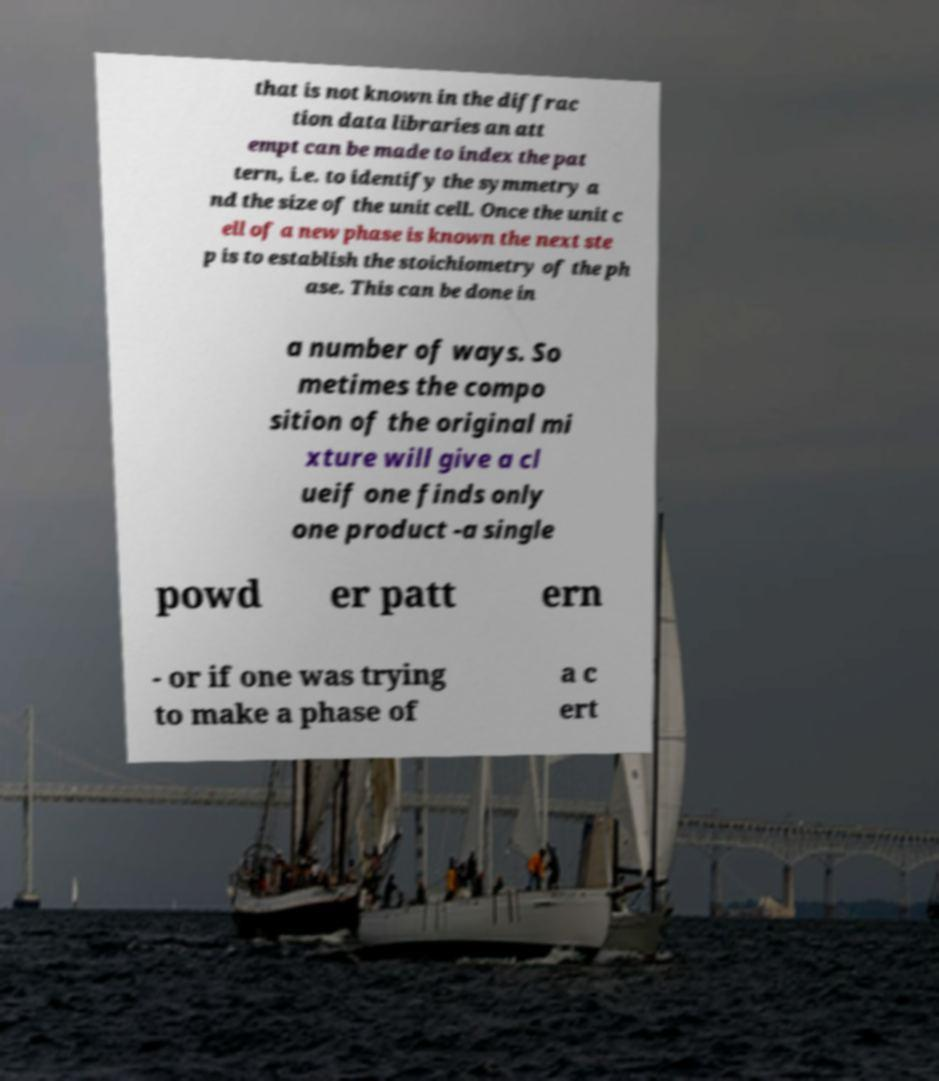I need the written content from this picture converted into text. Can you do that? that is not known in the diffrac tion data libraries an att empt can be made to index the pat tern, i.e. to identify the symmetry a nd the size of the unit cell. Once the unit c ell of a new phase is known the next ste p is to establish the stoichiometry of the ph ase. This can be done in a number of ways. So metimes the compo sition of the original mi xture will give a cl ueif one finds only one product -a single powd er patt ern - or if one was trying to make a phase of a c ert 